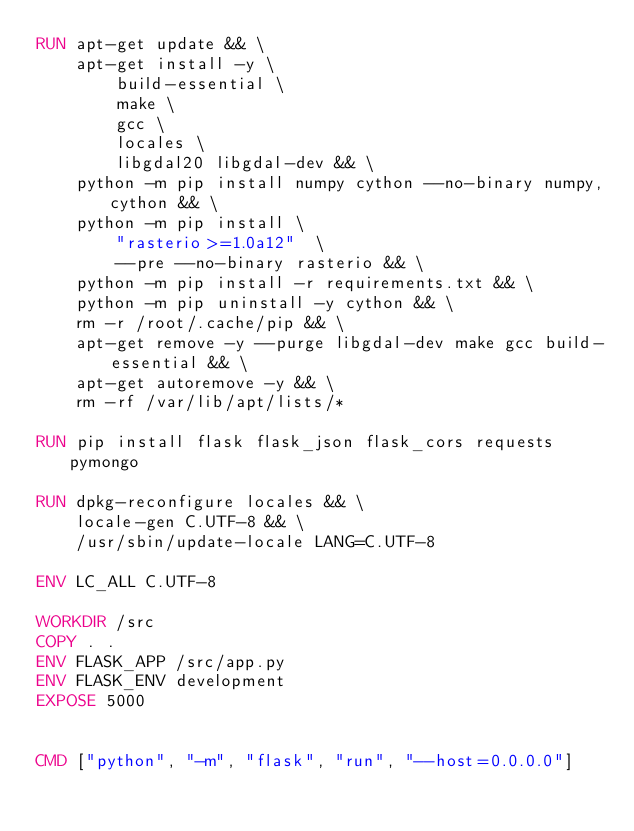<code> <loc_0><loc_0><loc_500><loc_500><_Dockerfile_>RUN apt-get update && \
    apt-get install -y \
        build-essential \
        make \
        gcc \
        locales \
        libgdal20 libgdal-dev && \
    python -m pip install numpy cython --no-binary numpy,cython && \
    python -m pip install \
        "rasterio>=1.0a12"  \
        --pre --no-binary rasterio && \
    python -m pip install -r requirements.txt && \
    python -m pip uninstall -y cython && \
    rm -r /root/.cache/pip && \
    apt-get remove -y --purge libgdal-dev make gcc build-essential && \
    apt-get autoremove -y && \
    rm -rf /var/lib/apt/lists/*

RUN pip install flask flask_json flask_cors requests pymongo 

RUN dpkg-reconfigure locales && \
    locale-gen C.UTF-8 && \
    /usr/sbin/update-locale LANG=C.UTF-8

ENV LC_ALL C.UTF-8

WORKDIR /src
COPY . .
ENV FLASK_APP /src/app.py
ENV FLASK_ENV development
EXPOSE 5000


CMD ["python", "-m", "flask", "run", "--host=0.0.0.0"]</code> 